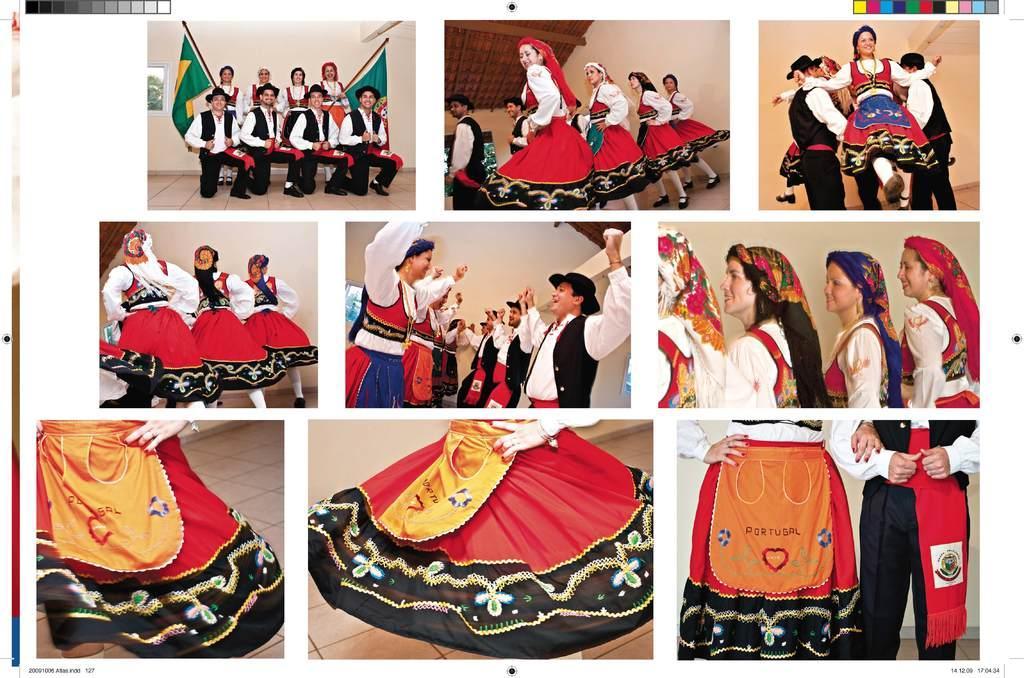Can you describe this image briefly? In this picture we can see photos on a white platform and in these photos we can see some people dancing, flags. 